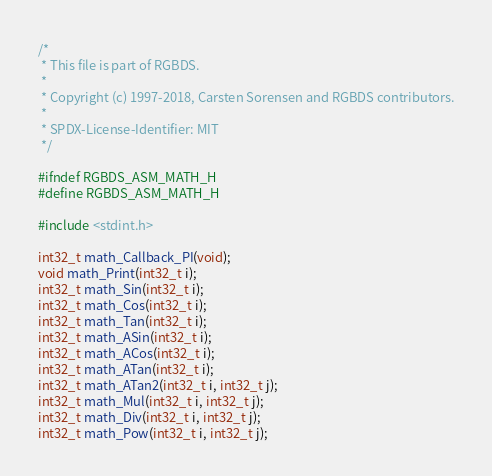<code> <loc_0><loc_0><loc_500><loc_500><_C_>/*
 * This file is part of RGBDS.
 *
 * Copyright (c) 1997-2018, Carsten Sorensen and RGBDS contributors.
 *
 * SPDX-License-Identifier: MIT
 */

#ifndef RGBDS_ASM_MATH_H
#define RGBDS_ASM_MATH_H

#include <stdint.h>

int32_t math_Callback_PI(void);
void math_Print(int32_t i);
int32_t math_Sin(int32_t i);
int32_t math_Cos(int32_t i);
int32_t math_Tan(int32_t i);
int32_t math_ASin(int32_t i);
int32_t math_ACos(int32_t i);
int32_t math_ATan(int32_t i);
int32_t math_ATan2(int32_t i, int32_t j);
int32_t math_Mul(int32_t i, int32_t j);
int32_t math_Div(int32_t i, int32_t j);
int32_t math_Pow(int32_t i, int32_t j);</code> 